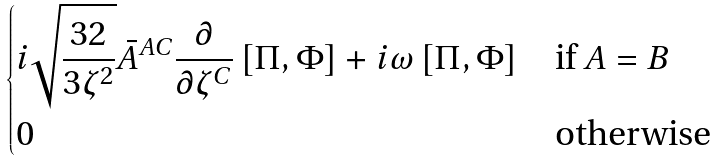Convert formula to latex. <formula><loc_0><loc_0><loc_500><loc_500>\begin{dcases} i \sqrt { \frac { 3 2 } { 3 \zeta ^ { 2 } } } \bar { A } ^ { A C } \frac { \partial } { \partial \zeta ^ { C } } \left [ \Pi , \Phi \right ] + i \omega \left [ \Pi , \Phi \right ] & \text {if } A = B \\ 0 & \text {otherwise} \end{dcases}</formula> 